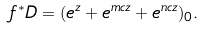Convert formula to latex. <formula><loc_0><loc_0><loc_500><loc_500>f ^ { * } D = ( e ^ { z } + e ^ { m c z } + e ^ { n c z } ) _ { 0 } .</formula> 